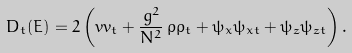<formula> <loc_0><loc_0><loc_500><loc_500>D _ { t } ( E ) = 2 \left ( v v _ { t } + \frac { g ^ { 2 } } { N ^ { 2 } } \, \rho \rho _ { t } + \psi _ { x } \psi _ { x t } + \psi _ { z } \psi _ { z t } \right ) .</formula> 